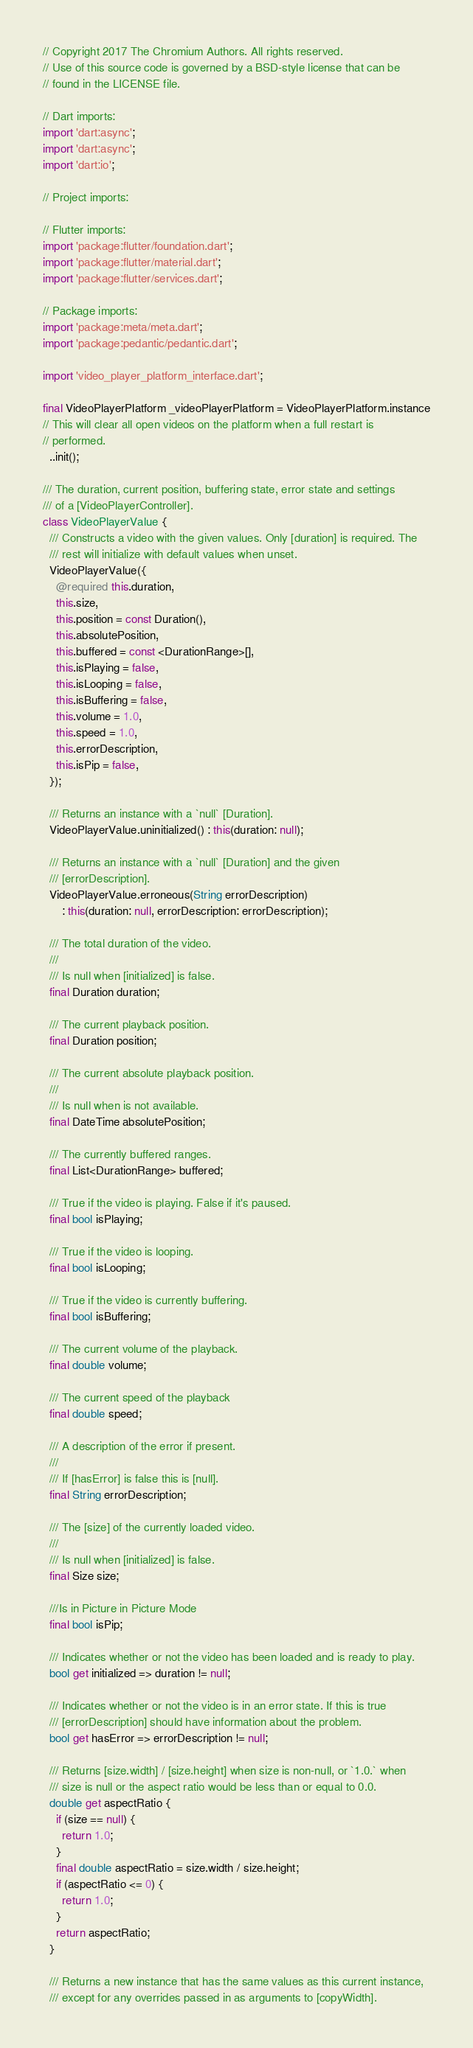Convert code to text. <code><loc_0><loc_0><loc_500><loc_500><_Dart_>// Copyright 2017 The Chromium Authors. All rights reserved.
// Use of this source code is governed by a BSD-style license that can be
// found in the LICENSE file.

// Dart imports:
import 'dart:async';
import 'dart:async';
import 'dart:io';

// Project imports:

// Flutter imports:
import 'package:flutter/foundation.dart';
import 'package:flutter/material.dart';
import 'package:flutter/services.dart';

// Package imports:
import 'package:meta/meta.dart';
import 'package:pedantic/pedantic.dart';

import 'video_player_platform_interface.dart';

final VideoPlayerPlatform _videoPlayerPlatform = VideoPlayerPlatform.instance
// This will clear all open videos on the platform when a full restart is
// performed.
  ..init();

/// The duration, current position, buffering state, error state and settings
/// of a [VideoPlayerController].
class VideoPlayerValue {
  /// Constructs a video with the given values. Only [duration] is required. The
  /// rest will initialize with default values when unset.
  VideoPlayerValue({
    @required this.duration,
    this.size,
    this.position = const Duration(),
    this.absolutePosition,
    this.buffered = const <DurationRange>[],
    this.isPlaying = false,
    this.isLooping = false,
    this.isBuffering = false,
    this.volume = 1.0,
    this.speed = 1.0,
    this.errorDescription,
    this.isPip = false,
  });

  /// Returns an instance with a `null` [Duration].
  VideoPlayerValue.uninitialized() : this(duration: null);

  /// Returns an instance with a `null` [Duration] and the given
  /// [errorDescription].
  VideoPlayerValue.erroneous(String errorDescription)
      : this(duration: null, errorDescription: errorDescription);

  /// The total duration of the video.
  ///
  /// Is null when [initialized] is false.
  final Duration duration;

  /// The current playback position.
  final Duration position;

  /// The current absolute playback position.
  ///
  /// Is null when is not available.
  final DateTime absolutePosition;

  /// The currently buffered ranges.
  final List<DurationRange> buffered;

  /// True if the video is playing. False if it's paused.
  final bool isPlaying;

  /// True if the video is looping.
  final bool isLooping;

  /// True if the video is currently buffering.
  final bool isBuffering;

  /// The current volume of the playback.
  final double volume;

  /// The current speed of the playback
  final double speed;

  /// A description of the error if present.
  ///
  /// If [hasError] is false this is [null].
  final String errorDescription;

  /// The [size] of the currently loaded video.
  ///
  /// Is null when [initialized] is false.
  final Size size;

  ///Is in Picture in Picture Mode
  final bool isPip;

  /// Indicates whether or not the video has been loaded and is ready to play.
  bool get initialized => duration != null;

  /// Indicates whether or not the video is in an error state. If this is true
  /// [errorDescription] should have information about the problem.
  bool get hasError => errorDescription != null;

  /// Returns [size.width] / [size.height] when size is non-null, or `1.0.` when
  /// size is null or the aspect ratio would be less than or equal to 0.0.
  double get aspectRatio {
    if (size == null) {
      return 1.0;
    }
    final double aspectRatio = size.width / size.height;
    if (aspectRatio <= 0) {
      return 1.0;
    }
    return aspectRatio;
  }

  /// Returns a new instance that has the same values as this current instance,
  /// except for any overrides passed in as arguments to [copyWidth].</code> 